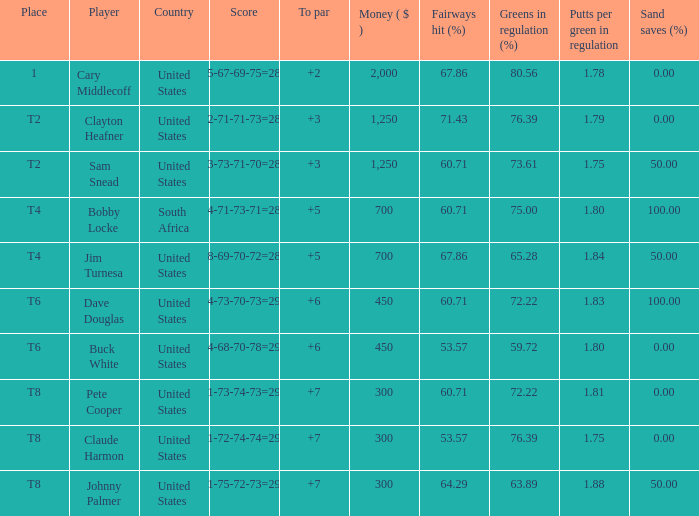What is Claude Harmon's Place? T8. 